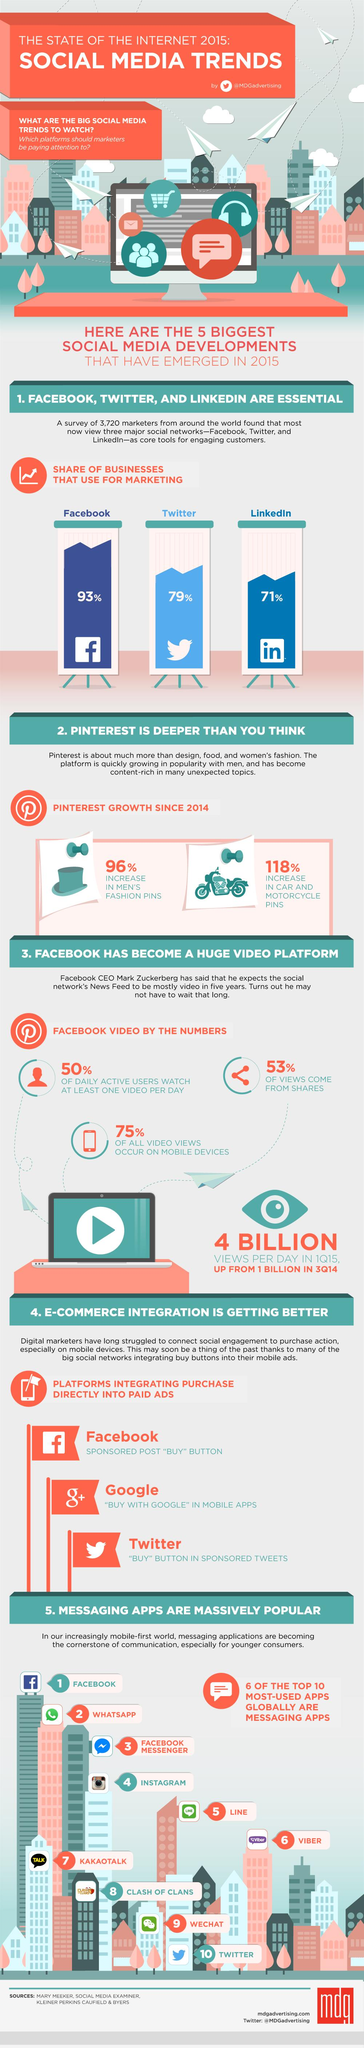Outline some significant characteristics in this image. The total percentage growth of Pinterest in men's fashion and car and motorcycle was 214%. It is estimated that approximately 47% of views do not come from shares. According to data, only 25% of all video views occur on mobile devices. 